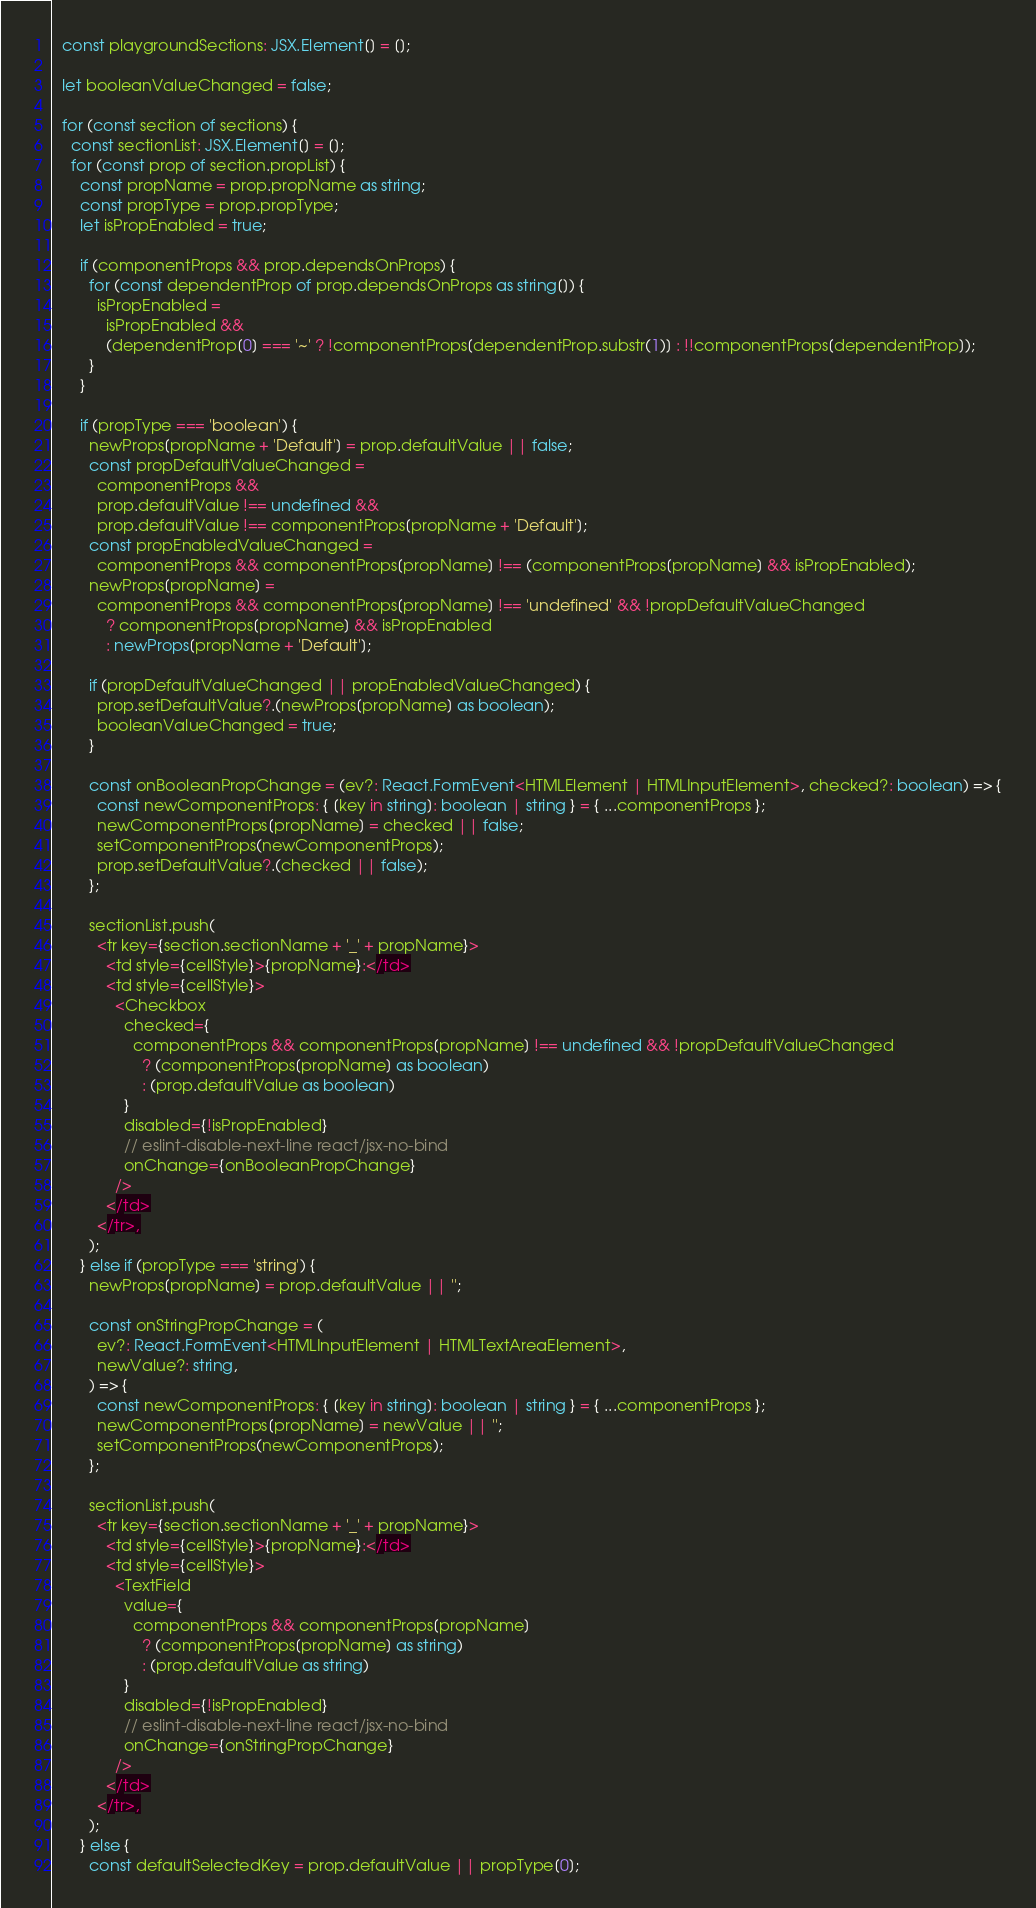<code> <loc_0><loc_0><loc_500><loc_500><_TypeScript_>
  const playgroundSections: JSX.Element[] = [];

  let booleanValueChanged = false;

  for (const section of sections) {
    const sectionList: JSX.Element[] = [];
    for (const prop of section.propList) {
      const propName = prop.propName as string;
      const propType = prop.propType;
      let isPropEnabled = true;

      if (componentProps && prop.dependsOnProps) {
        for (const dependentProp of prop.dependsOnProps as string[]) {
          isPropEnabled =
            isPropEnabled &&
            (dependentProp[0] === '~' ? !componentProps[dependentProp.substr(1)] : !!componentProps[dependentProp]);
        }
      }

      if (propType === 'boolean') {
        newProps[propName + 'Default'] = prop.defaultValue || false;
        const propDefaultValueChanged =
          componentProps &&
          prop.defaultValue !== undefined &&
          prop.defaultValue !== componentProps[propName + 'Default'];
        const propEnabledValueChanged =
          componentProps && componentProps[propName] !== (componentProps[propName] && isPropEnabled);
        newProps[propName] =
          componentProps && componentProps[propName] !== 'undefined' && !propDefaultValueChanged
            ? componentProps[propName] && isPropEnabled
            : newProps[propName + 'Default'];

        if (propDefaultValueChanged || propEnabledValueChanged) {
          prop.setDefaultValue?.(newProps[propName] as boolean);
          booleanValueChanged = true;
        }

        const onBooleanPropChange = (ev?: React.FormEvent<HTMLElement | HTMLInputElement>, checked?: boolean) => {
          const newComponentProps: { [key in string]: boolean | string } = { ...componentProps };
          newComponentProps[propName] = checked || false;
          setComponentProps(newComponentProps);
          prop.setDefaultValue?.(checked || false);
        };

        sectionList.push(
          <tr key={section.sectionName + '_' + propName}>
            <td style={cellStyle}>{propName}:</td>
            <td style={cellStyle}>
              <Checkbox
                checked={
                  componentProps && componentProps[propName] !== undefined && !propDefaultValueChanged
                    ? (componentProps[propName] as boolean)
                    : (prop.defaultValue as boolean)
                }
                disabled={!isPropEnabled}
                // eslint-disable-next-line react/jsx-no-bind
                onChange={onBooleanPropChange}
              />
            </td>
          </tr>,
        );
      } else if (propType === 'string') {
        newProps[propName] = prop.defaultValue || '';

        const onStringPropChange = (
          ev?: React.FormEvent<HTMLInputElement | HTMLTextAreaElement>,
          newValue?: string,
        ) => {
          const newComponentProps: { [key in string]: boolean | string } = { ...componentProps };
          newComponentProps[propName] = newValue || '';
          setComponentProps(newComponentProps);
        };

        sectionList.push(
          <tr key={section.sectionName + '_' + propName}>
            <td style={cellStyle}>{propName}:</td>
            <td style={cellStyle}>
              <TextField
                value={
                  componentProps && componentProps[propName]
                    ? (componentProps[propName] as string)
                    : (prop.defaultValue as string)
                }
                disabled={!isPropEnabled}
                // eslint-disable-next-line react/jsx-no-bind
                onChange={onStringPropChange}
              />
            </td>
          </tr>,
        );
      } else {
        const defaultSelectedKey = prop.defaultValue || propType[0];</code> 